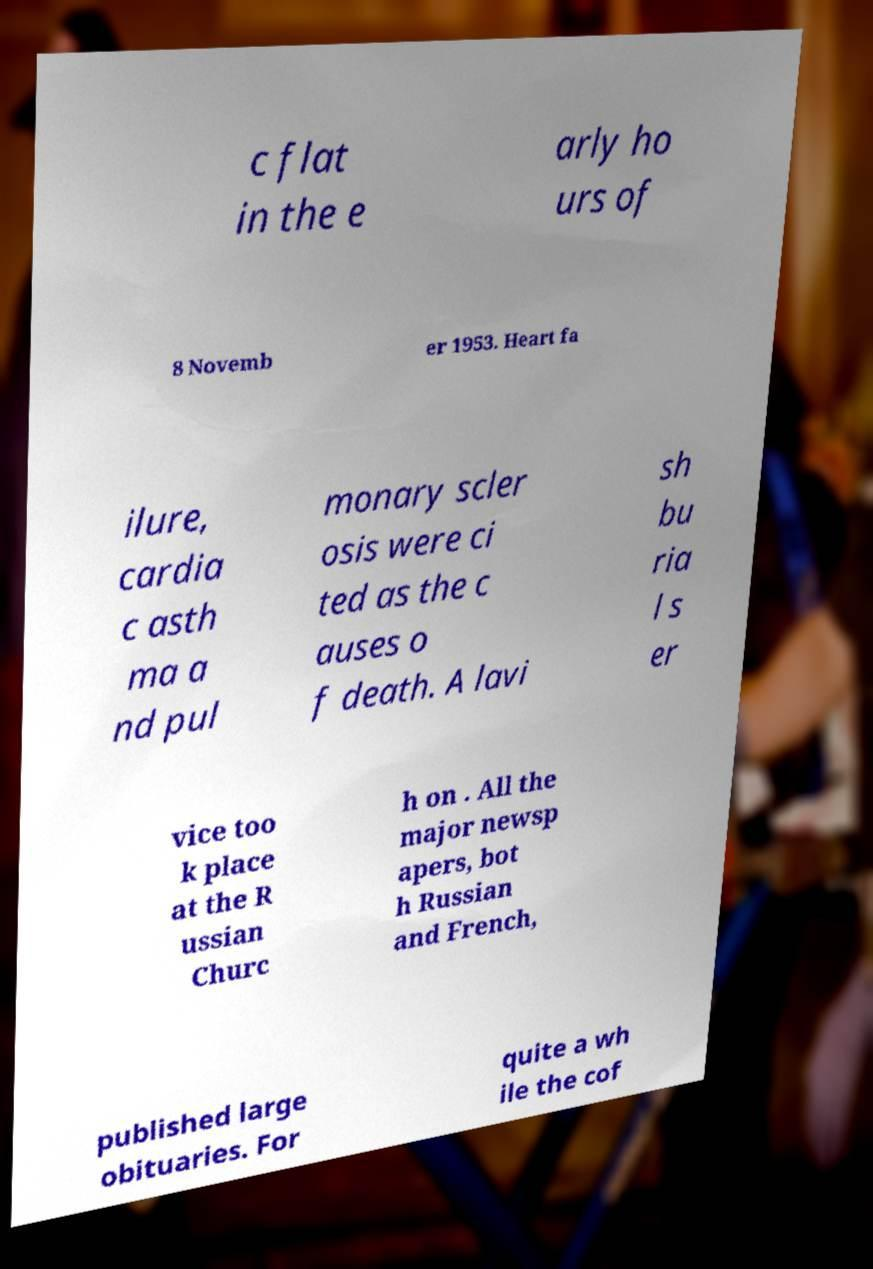I need the written content from this picture converted into text. Can you do that? c flat in the e arly ho urs of 8 Novemb er 1953. Heart fa ilure, cardia c asth ma a nd pul monary scler osis were ci ted as the c auses o f death. A lavi sh bu ria l s er vice too k place at the R ussian Churc h on . All the major newsp apers, bot h Russian and French, published large obituaries. For quite a wh ile the cof 